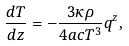Convert formula to latex. <formula><loc_0><loc_0><loc_500><loc_500>\frac { d T } { d z } = - \frac { 3 \kappa \rho } { 4 a c T ^ { 3 } } q ^ { z } ,</formula> 